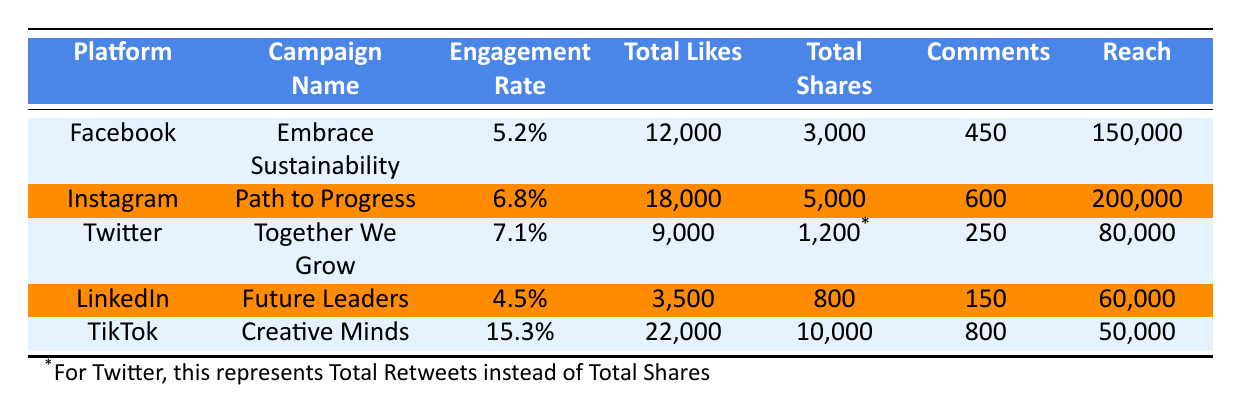What is the engagement rate for TikTok? The engagement rate for TikTok's campaign "Creative Minds" is directly listed in the table as 15.3%.
Answer: 15.3% Which platform had the highest total likes? The TikTok campaign "Creative Minds" has the highest total likes reported at 22,000, which can be seen in the total likes column.
Answer: 22,000 What are the total shares for the Twitter campaign? The table lists the total shares for the Twitter campaign "Together We Grow" as 1,200, which is documented in the total shares column, which represents total retweets for Twitter.
Answer: 1,200 Which campaign had the lowest engagement rate? By comparing the engagement rates, LinkedIn's campaign "Future Leaders" has the lowest at 4.5% as indicated in the engagement rate column.
Answer: 4.5% What is the difference in total likes between Instagram and Facebook? The total likes for Instagram is 18,000 and for Facebook is 12,000. The difference is calculated as 18,000 - 12,000 = 6,000.
Answer: 6,000 Which campaign had the greatest reach, and what was that reach? Referring to the reach column, Instagram's "Path to Progress" has the greatest reach of 200,000, surpassing other campaigns.
Answer: 200,000 If we average the engagement rates of all platforms, what is the average value? The engagement rates are 5.2%, 6.8%, 7.1%, 4.5%, and 15.3%. Summing them gives: (5.2 + 6.8 + 7.1 + 4.5 + 15.3) = 38.9%. Dividing by 5 gives the average of 38.9/5 = 7.78%.
Answer: 7.78% Is the total reach for TikTok greater than the total reach for Twitter? The total reach listed for TikTok is 50,000 while Twitter's total reach is 80,000. Since 50,000 is less than 80,000, the statement is false.
Answer: No How many total shares were there for the Instagram campaign? For the Instagram campaign "Path to Progress," the table lists total shares as 5,000.
Answer: 5,000 Which platform had a total of 600 comments? The table indicates that the Instagram campaign "Path to Progress" had 600 comments as noted in the comments column.
Answer: Instagram 